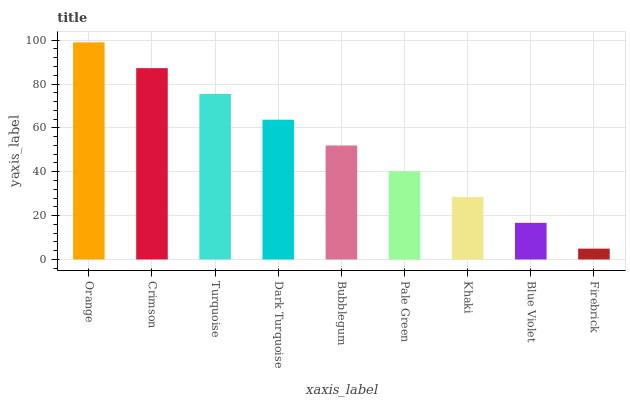Is Firebrick the minimum?
Answer yes or no. Yes. Is Orange the maximum?
Answer yes or no. Yes. Is Crimson the minimum?
Answer yes or no. No. Is Crimson the maximum?
Answer yes or no. No. Is Orange greater than Crimson?
Answer yes or no. Yes. Is Crimson less than Orange?
Answer yes or no. Yes. Is Crimson greater than Orange?
Answer yes or no. No. Is Orange less than Crimson?
Answer yes or no. No. Is Bubblegum the high median?
Answer yes or no. Yes. Is Bubblegum the low median?
Answer yes or no. Yes. Is Blue Violet the high median?
Answer yes or no. No. Is Crimson the low median?
Answer yes or no. No. 